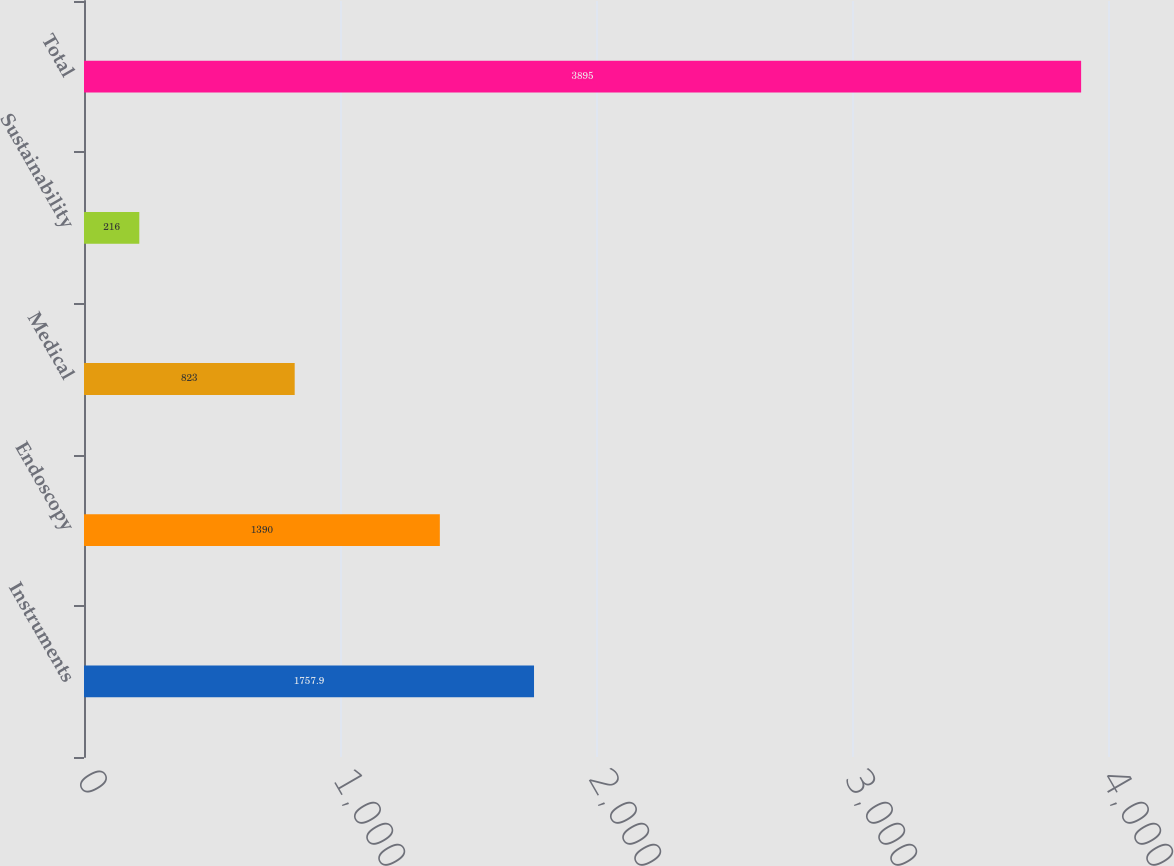Convert chart. <chart><loc_0><loc_0><loc_500><loc_500><bar_chart><fcel>Instruments<fcel>Endoscopy<fcel>Medical<fcel>Sustainability<fcel>Total<nl><fcel>1757.9<fcel>1390<fcel>823<fcel>216<fcel>3895<nl></chart> 